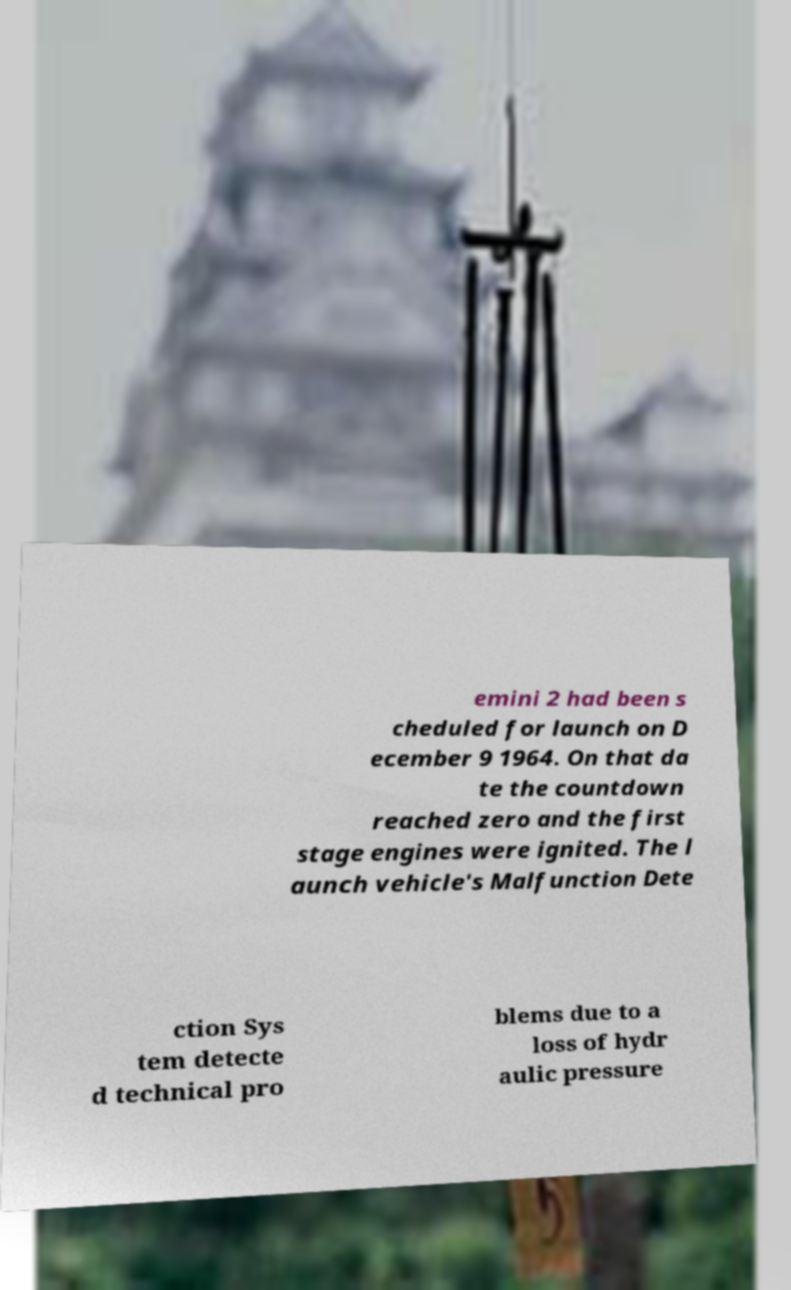Please identify and transcribe the text found in this image. emini 2 had been s cheduled for launch on D ecember 9 1964. On that da te the countdown reached zero and the first stage engines were ignited. The l aunch vehicle's Malfunction Dete ction Sys tem detecte d technical pro blems due to a loss of hydr aulic pressure 